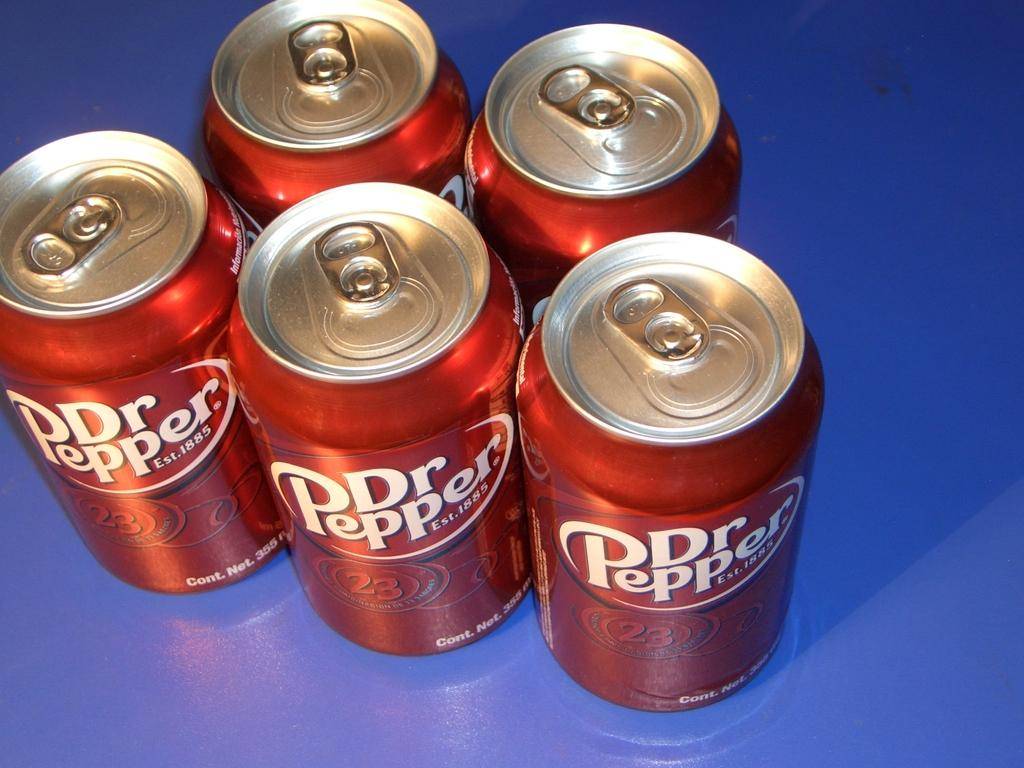Provide a one-sentence caption for the provided image. Five cans of Dr Pepper, two on top and three on the bottom. 